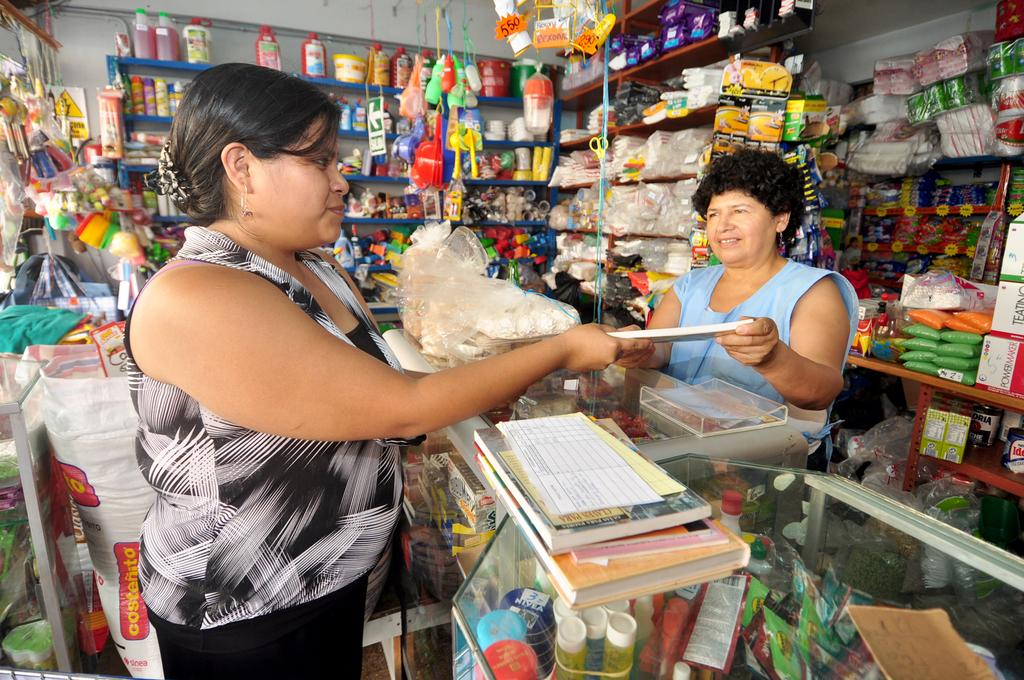<image>
Create a compact narrative representing the image presented. A woman with a black and white shirt standing in front of a large sack labeled Costenito. 